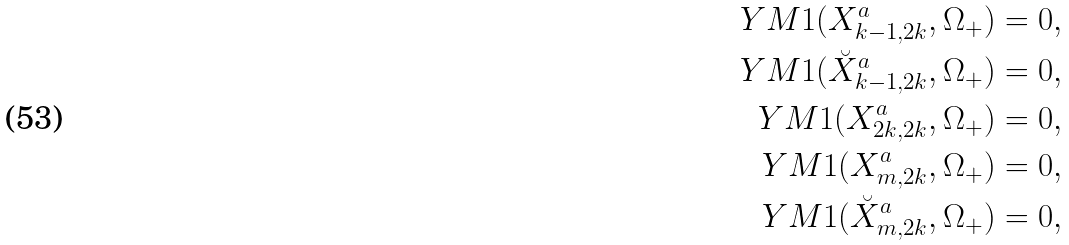<formula> <loc_0><loc_0><loc_500><loc_500>Y M 1 ( X _ { k - 1 , 2 k } ^ { a } , \Omega _ { + } ) = 0 , \\ Y M 1 ( \breve { X } _ { k - 1 , 2 k } ^ { a } , \Omega _ { + } ) = 0 , \\ Y M 1 ( X _ { 2 k , 2 k } ^ { a } , \Omega _ { + } ) = 0 , \\ Y M 1 ( X _ { m , 2 k } ^ { a } , \Omega _ { + } ) = 0 , \\ Y M 1 ( \breve { X } _ { m , 2 k } ^ { a } , \Omega _ { + } ) = 0 , \\</formula> 